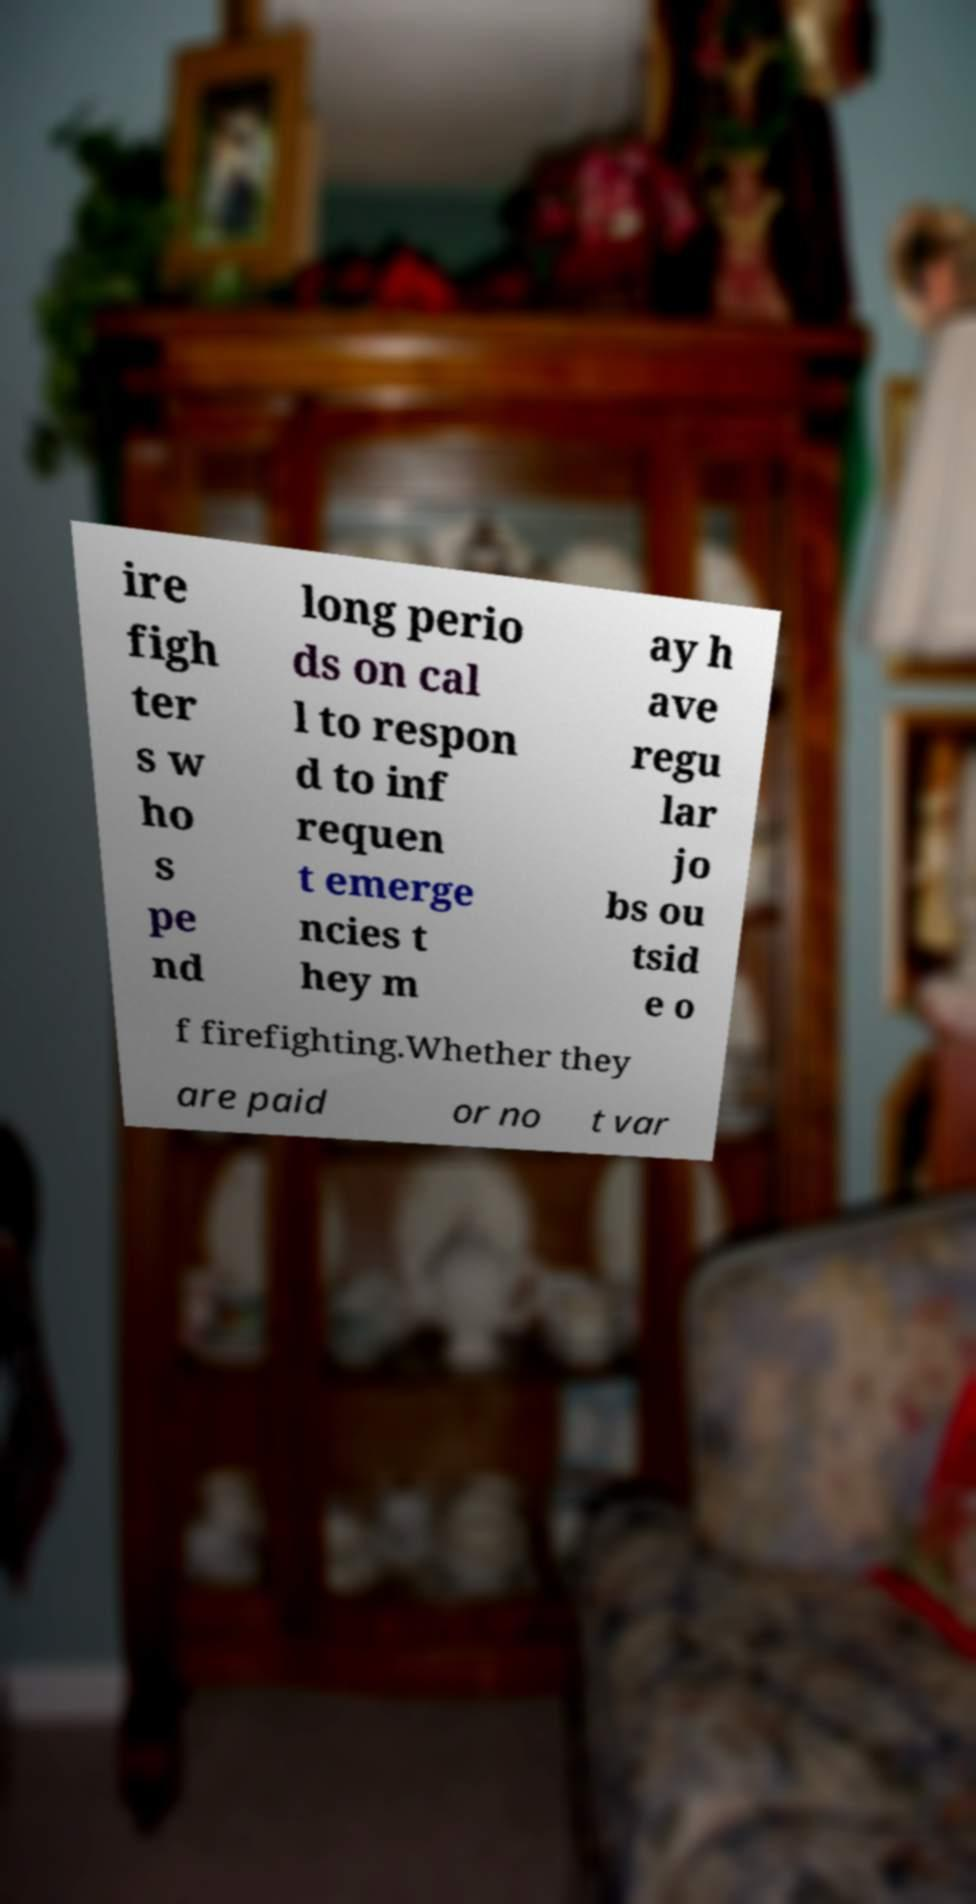What messages or text are displayed in this image? I need them in a readable, typed format. ire figh ter s w ho s pe nd long perio ds on cal l to respon d to inf requen t emerge ncies t hey m ay h ave regu lar jo bs ou tsid e o f firefighting.Whether they are paid or no t var 